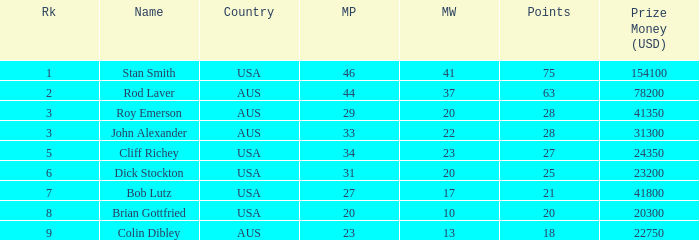How much prize money (in usd) did bob lutz win 41800.0. 